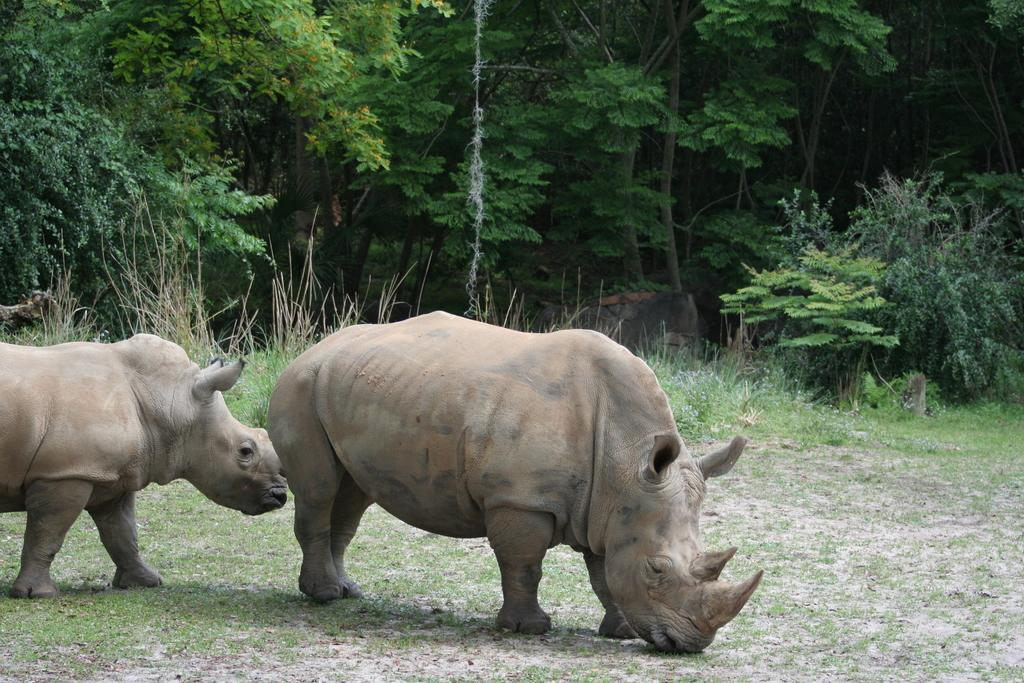What animals are in the foreground of the image? There are two rhinos in the foreground of the image. What is the surface on which the rhinos are standing? The rhinos are on the grass. What can be seen in the background of the image? There are trees in the background of the image. What type of light bulb is hanging from the tree in the image? There is no light bulb present in the image; it features two rhinos on the grass with trees in the background. 